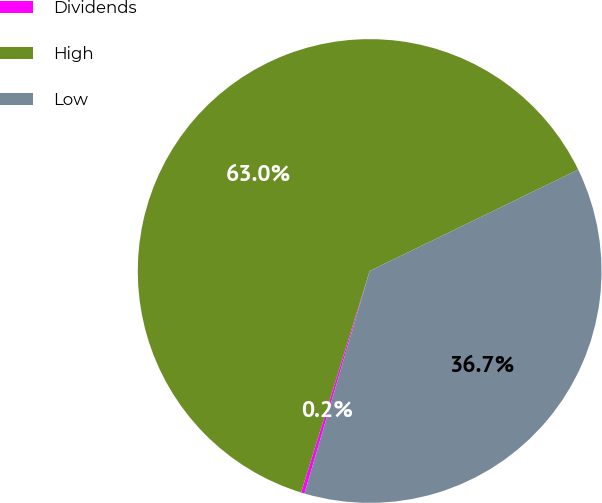Convert chart. <chart><loc_0><loc_0><loc_500><loc_500><pie_chart><fcel>Dividends<fcel>High<fcel>Low<nl><fcel>0.24%<fcel>63.03%<fcel>36.74%<nl></chart> 